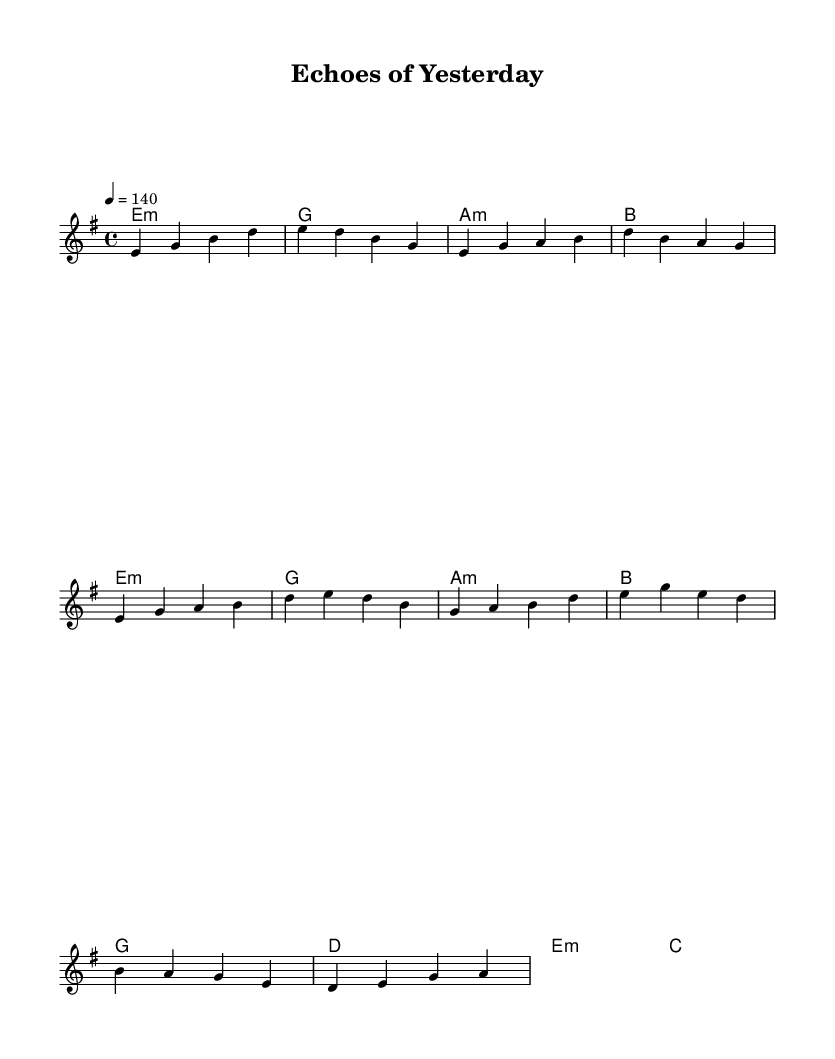What is the key signature of this music? The key signature is E minor, which has one sharp (F#). To identify the key signature, we look at the initial information in the music sheet: the key is marked as E minor.
Answer: E minor What is the time signature of this music? The time signature is 4/4, meaning there are four beats in a measure with a quarter note receiving one beat. This is indicated at the beginning of the score as part of the 'global' variable.
Answer: 4/4 What is the tempo marking of this piece? The tempo marking is 140, indicating the beats per minute. This information is stated as part of the global settings for the piece.
Answer: 140 What is the first chord in the piece? The first chord is E minor. This is noted in the harmonies section under the intro, where the first chord is labeled as e1:m.
Answer: E minor How many measures are there in the chorus section? There are four measures in the chorus section. To find this, we count the measures listed under the chorus in the harmony and melody sections, identifying each individual segment.
Answer: 4 Which emotion does the minor key typically convey in music like this? The minor key typically conveys a melancholic or nostalgic emotion. This aligns with the symphonic metal genre's use of darker themes tied to nostalgia and time travel.
Answer: Melancholic How does the structure of the piece reflect typical metal music elements? The structure includes clear sections (intro, verse, chorus), which is a common characteristic of metal music; it creates a contrast between melody and harmony and amplifies emotional themes. This can be deduced by the organization of the score, highlighting dynamic transitions.
Answer: Contrast 